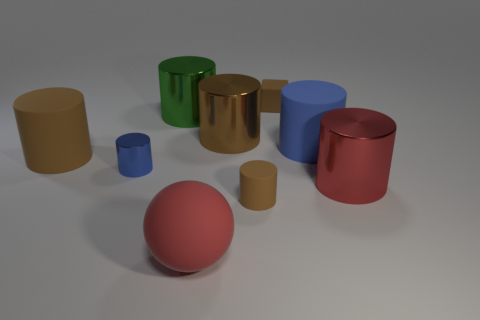How many brown cylinders must be subtracted to get 1 brown cylinders? 2 Subtract all purple balls. How many brown cylinders are left? 3 Subtract all green cylinders. How many cylinders are left? 6 Subtract all tiny blue metallic cylinders. How many cylinders are left? 6 Subtract all blue cylinders. Subtract all brown spheres. How many cylinders are left? 5 Add 1 blue rubber objects. How many objects exist? 10 Subtract all cubes. How many objects are left? 8 Subtract 0 blue cubes. How many objects are left? 9 Subtract all small gray rubber cylinders. Subtract all blue things. How many objects are left? 7 Add 1 large green objects. How many large green objects are left? 2 